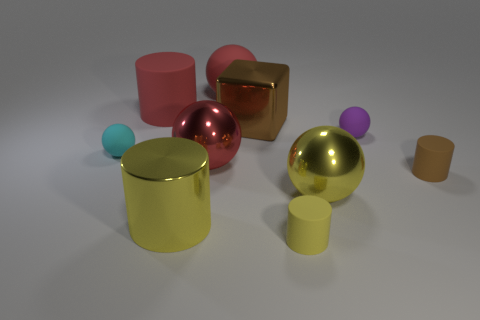Is there anything else that has the same material as the tiny cyan ball?
Your answer should be very brief. Yes. How many other objects are there of the same color as the big metal block?
Keep it short and to the point. 1. What number of shiny objects are big spheres or big yellow spheres?
Ensure brevity in your answer.  2. What color is the object that is both in front of the small purple rubber object and on the right side of the yellow metallic ball?
Offer a very short reply. Brown. There is a red ball in front of the purple rubber sphere; is it the same size as the tiny purple ball?
Your answer should be compact. No. What number of things are metal spheres that are to the left of the cube or tiny metallic objects?
Your response must be concise. 1. Are there any brown rubber things that have the same size as the yellow metallic cylinder?
Your response must be concise. No. There is a yellow sphere that is the same size as the metal cylinder; what is its material?
Provide a short and direct response. Metal. There is a tiny matte object that is to the left of the big yellow metal ball and to the right of the metallic cylinder; what is its shape?
Your answer should be very brief. Cylinder. There is a large rubber thing that is to the right of the large red rubber cylinder; what color is it?
Keep it short and to the point. Red. 